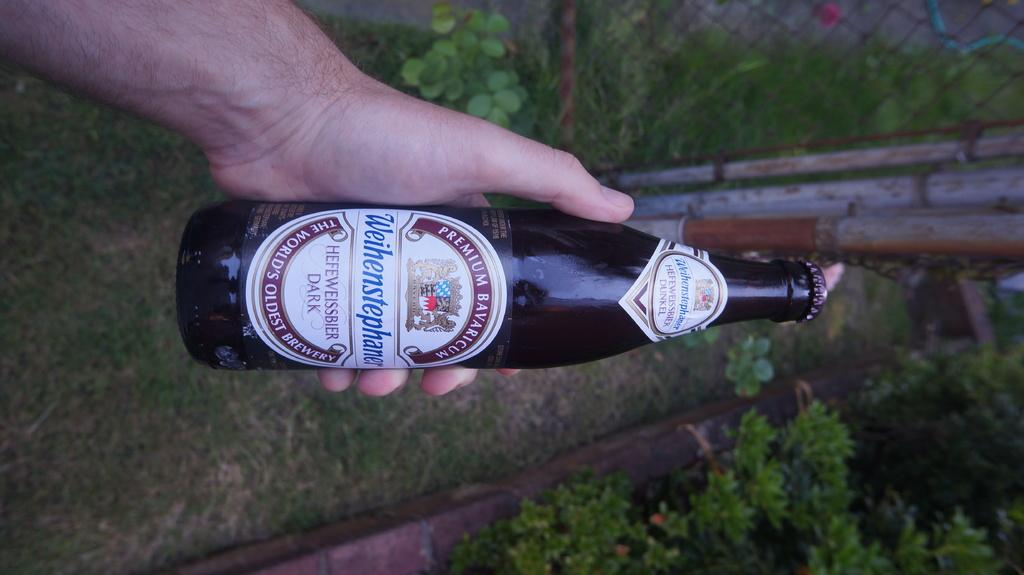<image>
Describe the image concisely. A bottle of german Weihenstephaner Heffweissbier dark beer held horizantally. 